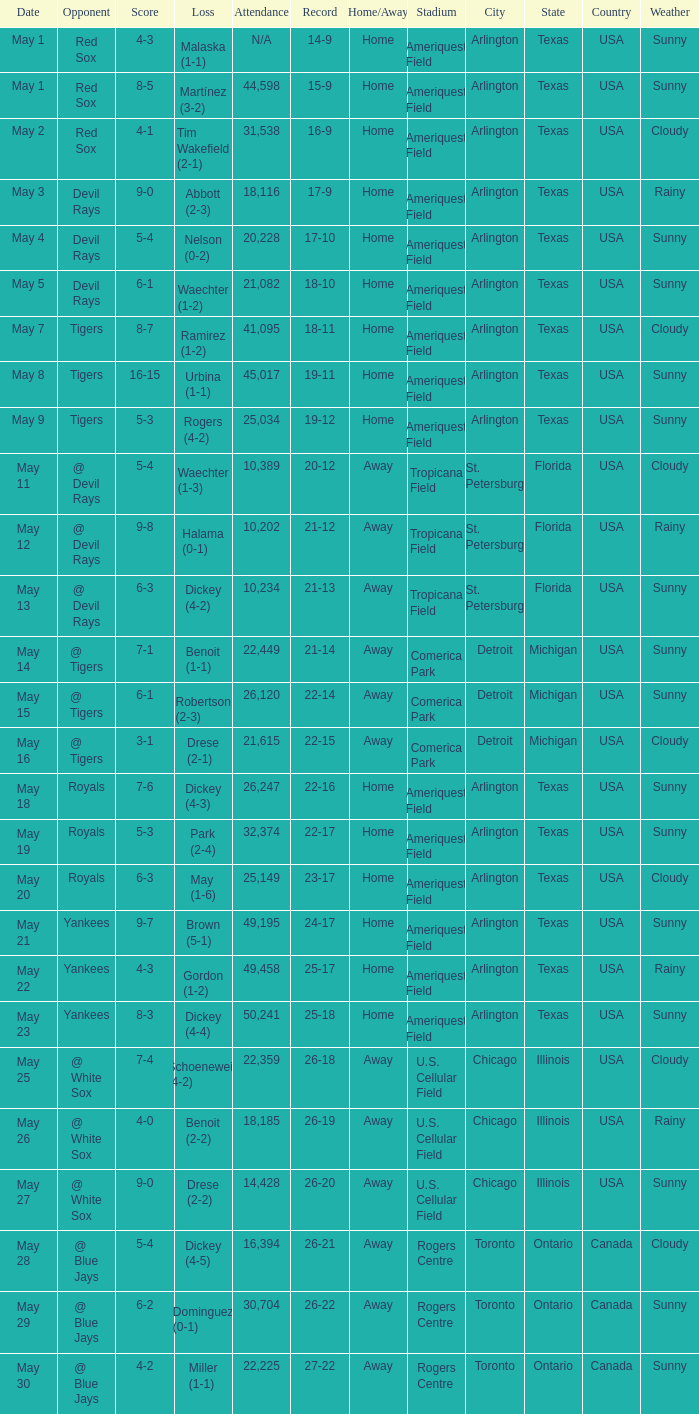What is the score of the game attended by 25,034? 5-3. 